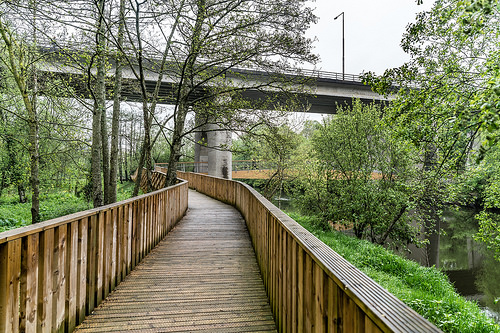<image>
Can you confirm if the bridge is on the walkway? No. The bridge is not positioned on the walkway. They may be near each other, but the bridge is not supported by or resting on top of the walkway. 